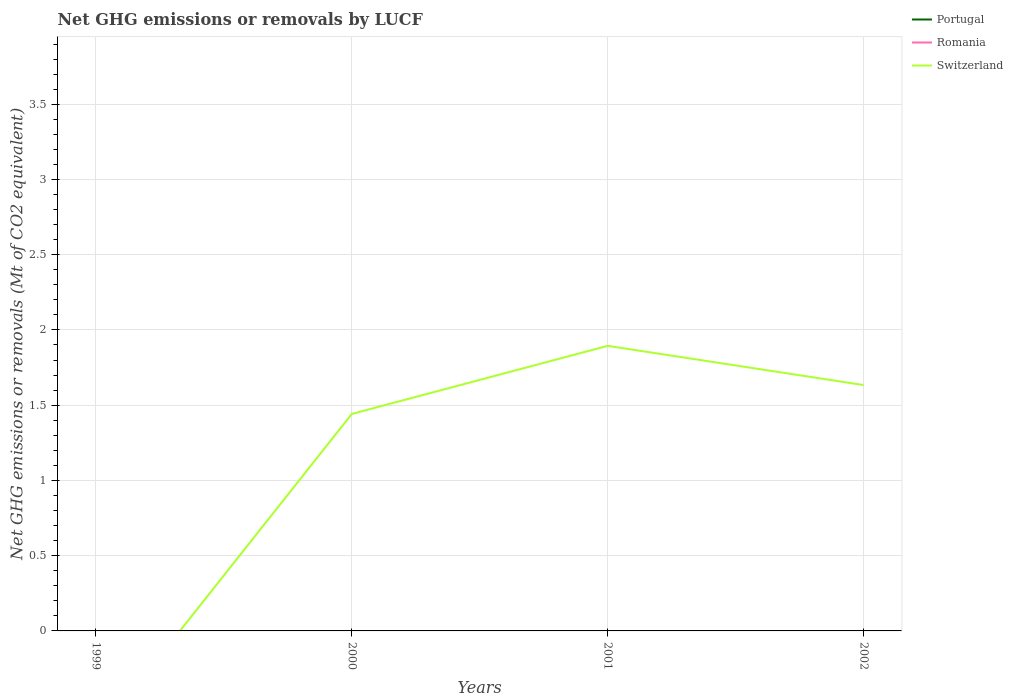How many different coloured lines are there?
Offer a very short reply. 1. Does the line corresponding to Switzerland intersect with the line corresponding to Portugal?
Your response must be concise. No. Is the number of lines equal to the number of legend labels?
Keep it short and to the point. No. What is the total net GHG emissions or removals by LUCF in Switzerland in the graph?
Your answer should be very brief. -0.19. What is the difference between the highest and the second highest net GHG emissions or removals by LUCF in Switzerland?
Provide a succinct answer. 1.89. What is the difference between the highest and the lowest net GHG emissions or removals by LUCF in Switzerland?
Your answer should be very brief. 3. Is the net GHG emissions or removals by LUCF in Switzerland strictly greater than the net GHG emissions or removals by LUCF in Romania over the years?
Your answer should be very brief. No. How many years are there in the graph?
Make the answer very short. 4. Does the graph contain grids?
Ensure brevity in your answer.  Yes. Where does the legend appear in the graph?
Make the answer very short. Top right. How many legend labels are there?
Offer a very short reply. 3. What is the title of the graph?
Keep it short and to the point. Net GHG emissions or removals by LUCF. Does "Arab World" appear as one of the legend labels in the graph?
Make the answer very short. No. What is the label or title of the Y-axis?
Provide a short and direct response. Net GHG emissions or removals (Mt of CO2 equivalent). What is the Net GHG emissions or removals (Mt of CO2 equivalent) of Portugal in 1999?
Offer a very short reply. 0. What is the Net GHG emissions or removals (Mt of CO2 equivalent) in Romania in 1999?
Offer a terse response. 0. What is the Net GHG emissions or removals (Mt of CO2 equivalent) of Switzerland in 2000?
Your response must be concise. 1.44. What is the Net GHG emissions or removals (Mt of CO2 equivalent) of Switzerland in 2001?
Make the answer very short. 1.89. What is the Net GHG emissions or removals (Mt of CO2 equivalent) in Switzerland in 2002?
Your answer should be very brief. 1.63. Across all years, what is the maximum Net GHG emissions or removals (Mt of CO2 equivalent) of Switzerland?
Offer a terse response. 1.89. Across all years, what is the minimum Net GHG emissions or removals (Mt of CO2 equivalent) of Switzerland?
Provide a short and direct response. 0. What is the total Net GHG emissions or removals (Mt of CO2 equivalent) in Romania in the graph?
Offer a terse response. 0. What is the total Net GHG emissions or removals (Mt of CO2 equivalent) in Switzerland in the graph?
Provide a short and direct response. 4.97. What is the difference between the Net GHG emissions or removals (Mt of CO2 equivalent) of Switzerland in 2000 and that in 2001?
Provide a short and direct response. -0.45. What is the difference between the Net GHG emissions or removals (Mt of CO2 equivalent) of Switzerland in 2000 and that in 2002?
Your answer should be very brief. -0.19. What is the difference between the Net GHG emissions or removals (Mt of CO2 equivalent) in Switzerland in 2001 and that in 2002?
Your answer should be compact. 0.26. What is the average Net GHG emissions or removals (Mt of CO2 equivalent) of Portugal per year?
Provide a short and direct response. 0. What is the average Net GHG emissions or removals (Mt of CO2 equivalent) of Romania per year?
Keep it short and to the point. 0. What is the average Net GHG emissions or removals (Mt of CO2 equivalent) of Switzerland per year?
Provide a short and direct response. 1.24. What is the ratio of the Net GHG emissions or removals (Mt of CO2 equivalent) of Switzerland in 2000 to that in 2001?
Keep it short and to the point. 0.76. What is the ratio of the Net GHG emissions or removals (Mt of CO2 equivalent) in Switzerland in 2000 to that in 2002?
Your answer should be very brief. 0.88. What is the ratio of the Net GHG emissions or removals (Mt of CO2 equivalent) of Switzerland in 2001 to that in 2002?
Ensure brevity in your answer.  1.16. What is the difference between the highest and the second highest Net GHG emissions or removals (Mt of CO2 equivalent) in Switzerland?
Your response must be concise. 0.26. What is the difference between the highest and the lowest Net GHG emissions or removals (Mt of CO2 equivalent) of Switzerland?
Provide a succinct answer. 1.89. 